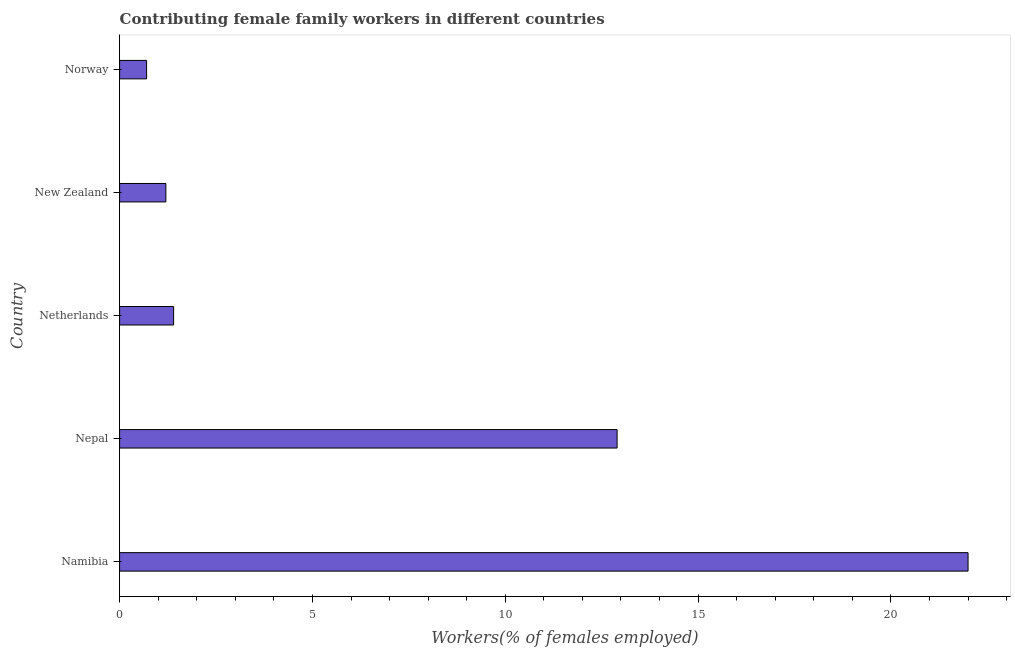Does the graph contain grids?
Offer a very short reply. No. What is the title of the graph?
Keep it short and to the point. Contributing female family workers in different countries. What is the label or title of the X-axis?
Make the answer very short. Workers(% of females employed). What is the label or title of the Y-axis?
Ensure brevity in your answer.  Country. What is the contributing female family workers in Netherlands?
Provide a succinct answer. 1.4. Across all countries, what is the maximum contributing female family workers?
Ensure brevity in your answer.  22. Across all countries, what is the minimum contributing female family workers?
Give a very brief answer. 0.7. In which country was the contributing female family workers maximum?
Offer a terse response. Namibia. What is the sum of the contributing female family workers?
Keep it short and to the point. 38.2. What is the average contributing female family workers per country?
Offer a terse response. 7.64. What is the median contributing female family workers?
Offer a very short reply. 1.4. In how many countries, is the contributing female family workers greater than 22 %?
Provide a short and direct response. 0. What is the ratio of the contributing female family workers in Nepal to that in Norway?
Offer a terse response. 18.43. Is the sum of the contributing female family workers in Namibia and New Zealand greater than the maximum contributing female family workers across all countries?
Ensure brevity in your answer.  Yes. What is the difference between the highest and the lowest contributing female family workers?
Ensure brevity in your answer.  21.3. What is the difference between two consecutive major ticks on the X-axis?
Make the answer very short. 5. What is the Workers(% of females employed) in Nepal?
Give a very brief answer. 12.9. What is the Workers(% of females employed) in Netherlands?
Ensure brevity in your answer.  1.4. What is the Workers(% of females employed) in New Zealand?
Provide a succinct answer. 1.2. What is the Workers(% of females employed) of Norway?
Give a very brief answer. 0.7. What is the difference between the Workers(% of females employed) in Namibia and Nepal?
Offer a very short reply. 9.1. What is the difference between the Workers(% of females employed) in Namibia and Netherlands?
Give a very brief answer. 20.6. What is the difference between the Workers(% of females employed) in Namibia and New Zealand?
Your response must be concise. 20.8. What is the difference between the Workers(% of females employed) in Namibia and Norway?
Ensure brevity in your answer.  21.3. What is the difference between the Workers(% of females employed) in Netherlands and New Zealand?
Give a very brief answer. 0.2. What is the difference between the Workers(% of females employed) in New Zealand and Norway?
Offer a terse response. 0.5. What is the ratio of the Workers(% of females employed) in Namibia to that in Nepal?
Your response must be concise. 1.71. What is the ratio of the Workers(% of females employed) in Namibia to that in Netherlands?
Offer a terse response. 15.71. What is the ratio of the Workers(% of females employed) in Namibia to that in New Zealand?
Ensure brevity in your answer.  18.33. What is the ratio of the Workers(% of females employed) in Namibia to that in Norway?
Give a very brief answer. 31.43. What is the ratio of the Workers(% of females employed) in Nepal to that in Netherlands?
Give a very brief answer. 9.21. What is the ratio of the Workers(% of females employed) in Nepal to that in New Zealand?
Give a very brief answer. 10.75. What is the ratio of the Workers(% of females employed) in Nepal to that in Norway?
Offer a terse response. 18.43. What is the ratio of the Workers(% of females employed) in Netherlands to that in New Zealand?
Offer a terse response. 1.17. What is the ratio of the Workers(% of females employed) in New Zealand to that in Norway?
Provide a succinct answer. 1.71. 